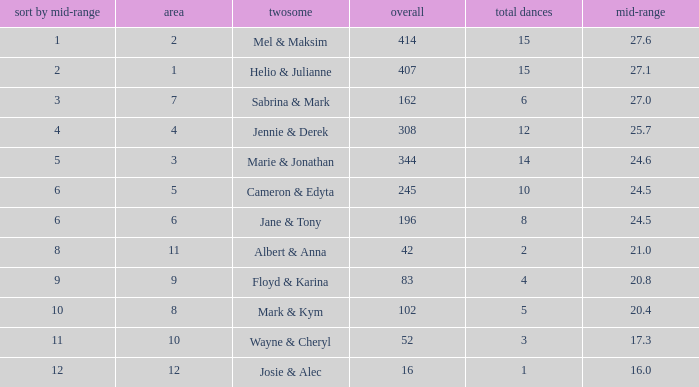What is the average place for a couple with the rank by average of 9 and total smaller than 83? None. 